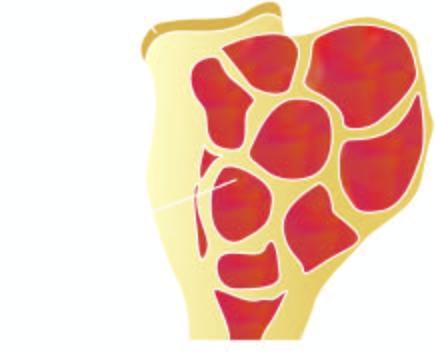what shows circumscribed, dark tan, haemorrhagic and necrotic tumour?
Answer the question using a single word or phrase. Sectioned surface 